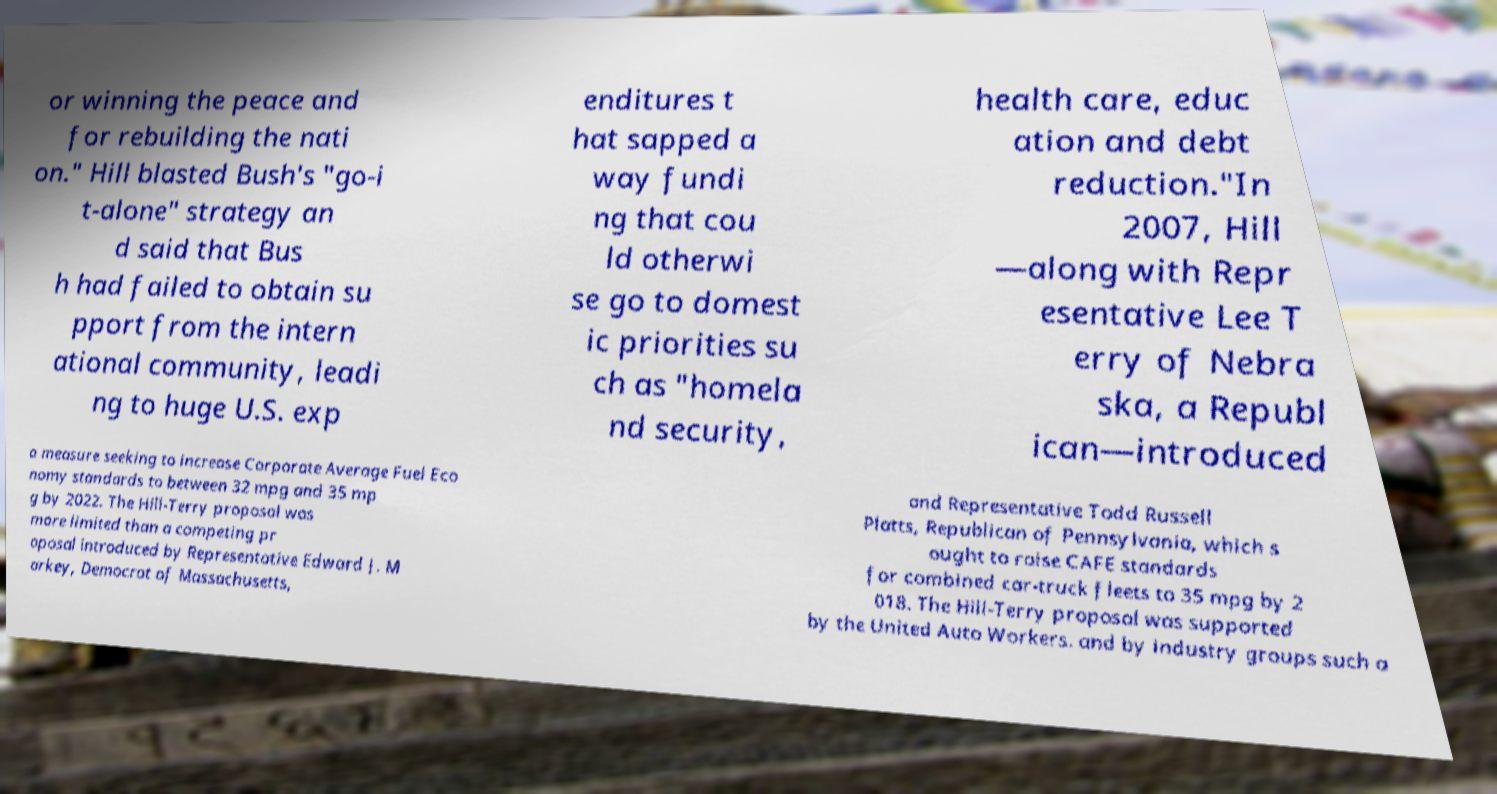Could you assist in decoding the text presented in this image and type it out clearly? or winning the peace and for rebuilding the nati on." Hill blasted Bush's "go-i t-alone" strategy an d said that Bus h had failed to obtain su pport from the intern ational community, leadi ng to huge U.S. exp enditures t hat sapped a way fundi ng that cou ld otherwi se go to domest ic priorities su ch as "homela nd security, health care, educ ation and debt reduction."In 2007, Hill —along with Repr esentative Lee T erry of Nebra ska, a Republ ican—introduced a measure seeking to increase Corporate Average Fuel Eco nomy standards to between 32 mpg and 35 mp g by 2022. The Hill-Terry proposal was more limited than a competing pr oposal introduced by Representative Edward J. M arkey, Democrat of Massachusetts, and Representative Todd Russell Platts, Republican of Pennsylvania, which s ought to raise CAFE standards for combined car-truck fleets to 35 mpg by 2 018. The Hill-Terry proposal was supported by the United Auto Workers. and by industry groups such a 